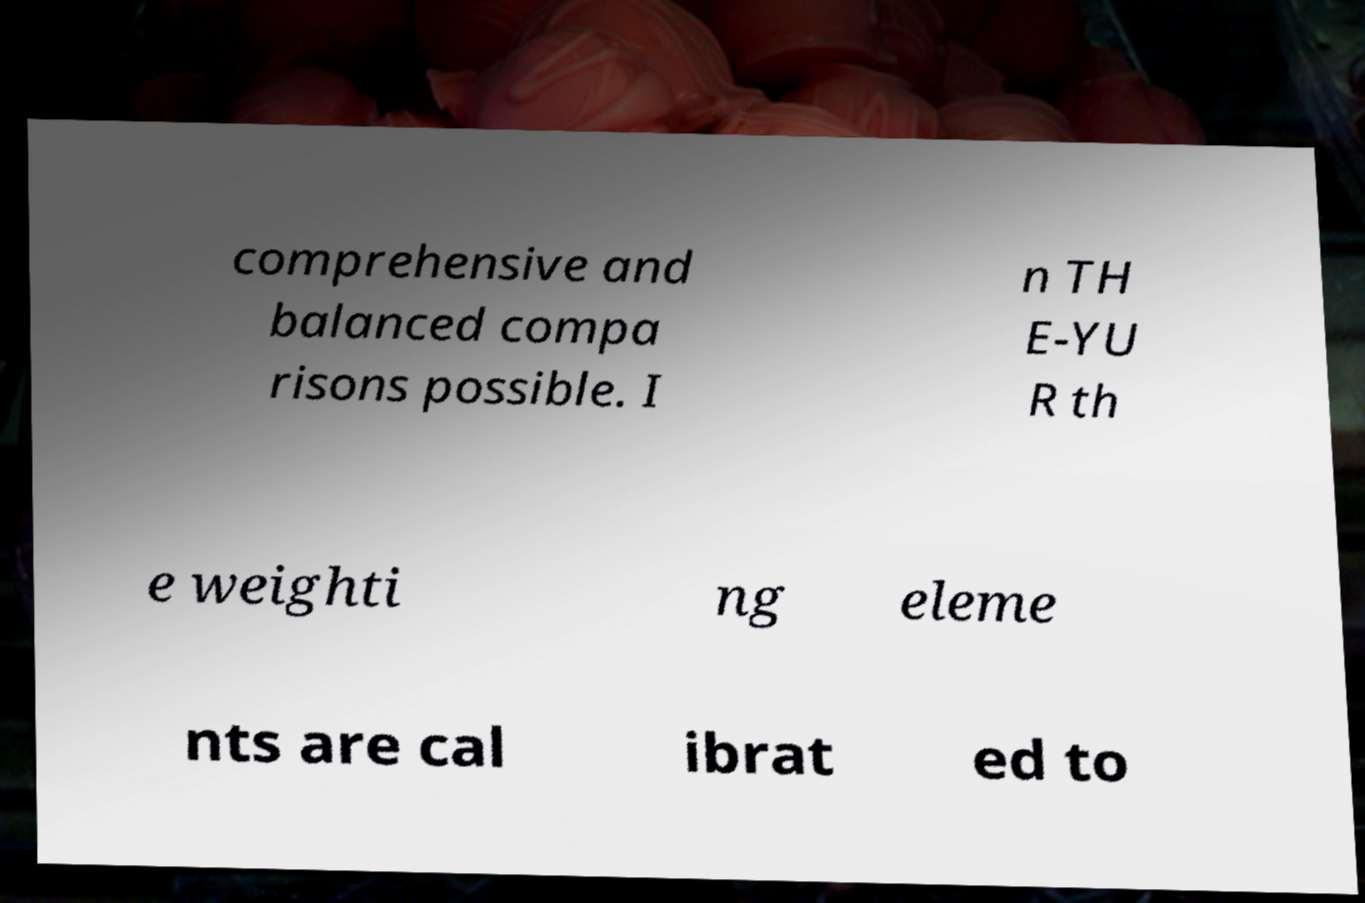Please identify and transcribe the text found in this image. comprehensive and balanced compa risons possible. I n TH E-YU R th e weighti ng eleme nts are cal ibrat ed to 